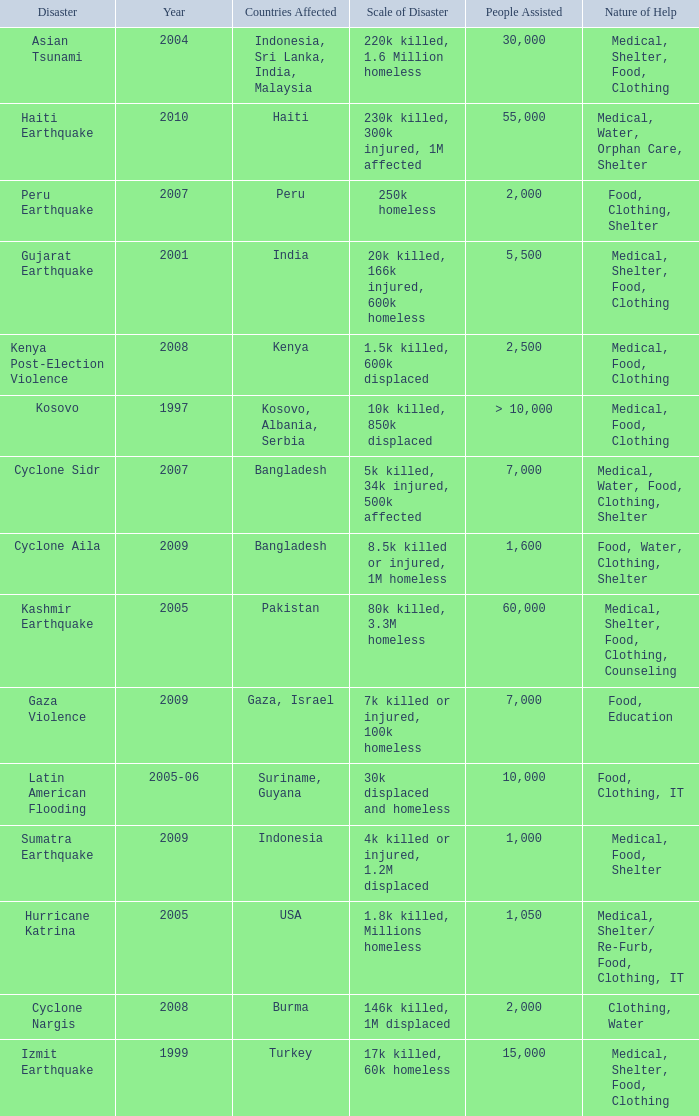In the disaster in which 1,000 people were helped, what was the nature of help? Medical, Food, Shelter. 